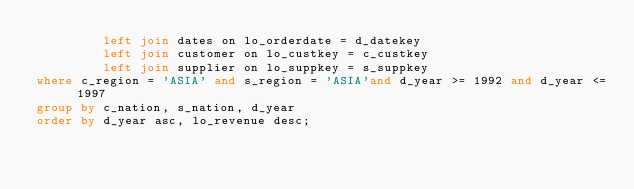<code> <loc_0><loc_0><loc_500><loc_500><_SQL_>         left join dates on lo_orderdate = d_datekey
         left join customer on lo_custkey = c_custkey
         left join supplier on lo_suppkey = s_suppkey
where c_region = 'ASIA' and s_region = 'ASIA'and d_year >= 1992 and d_year <= 1997
group by c_nation, s_nation, d_year
order by d_year asc, lo_revenue desc;
</code> 